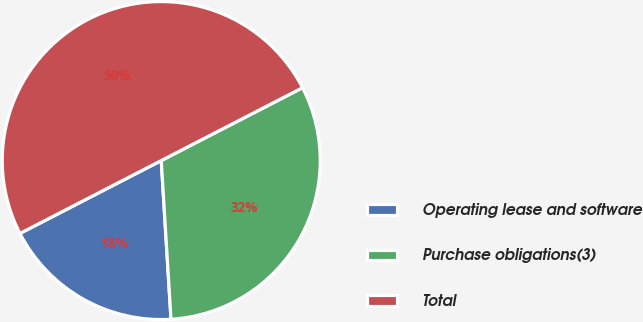Convert chart to OTSL. <chart><loc_0><loc_0><loc_500><loc_500><pie_chart><fcel>Operating lease and software<fcel>Purchase obligations(3)<fcel>Total<nl><fcel>18.4%<fcel>31.6%<fcel>50.0%<nl></chart> 